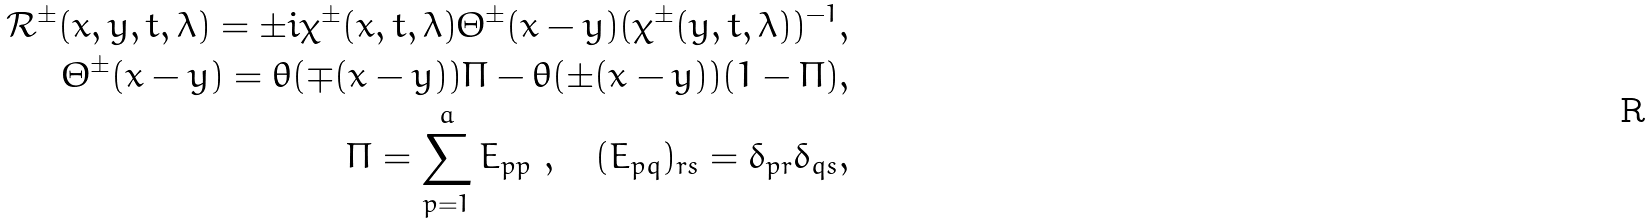Convert formula to latex. <formula><loc_0><loc_0><loc_500><loc_500>\mathcal { R } ^ { \pm } ( x , y , t , \lambda ) = \pm i \chi ^ { \pm } ( x , t , \lambda ) \Theta ^ { \pm } ( x - y ) ( \chi ^ { \pm } ( y , t , \lambda ) ) ^ { - 1 } , \\ \Theta ^ { \pm } ( x - y ) = \theta ( \mp ( x - y ) ) \Pi - \theta ( \pm ( x - y ) ) ( 1 - \Pi ) , \\ \Pi = \sum ^ { a } _ { p = 1 } E _ { p p } \ , \quad ( E _ { p q } ) _ { r s } = \delta _ { p r } \delta _ { q s } ,</formula> 